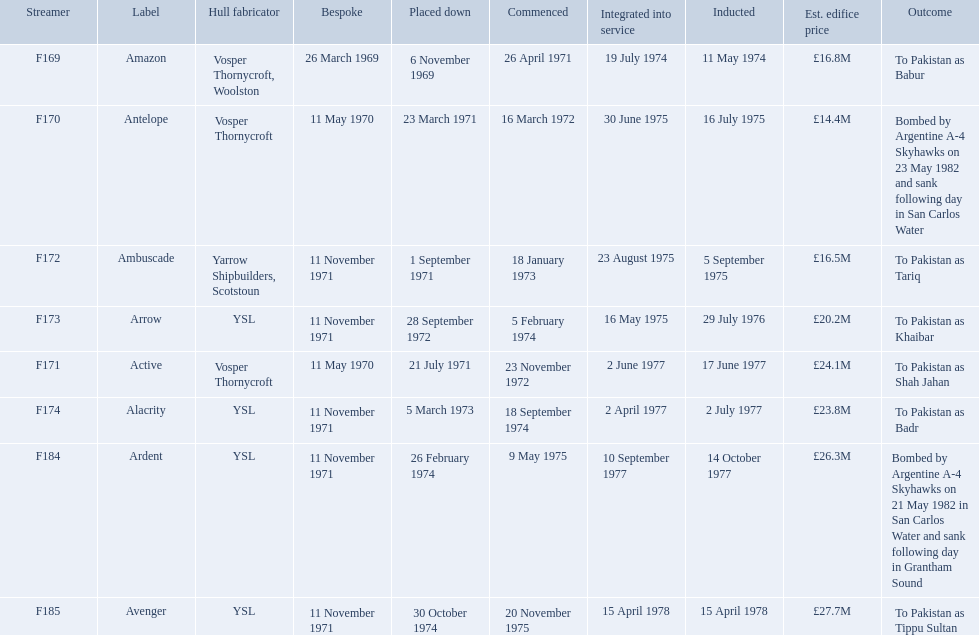Which type 21 frigate ships were to be built by ysl in the 1970s? Arrow, Alacrity, Ardent, Avenger. Of these ships, which one had the highest estimated building cost? Avenger. What were the estimated building costs of the frigates? £16.8M, £14.4M, £16.5M, £20.2M, £24.1M, £23.8M, £26.3M, £27.7M. Which of these is the largest? £27.7M. What ship name does that correspond to? Avenger. 